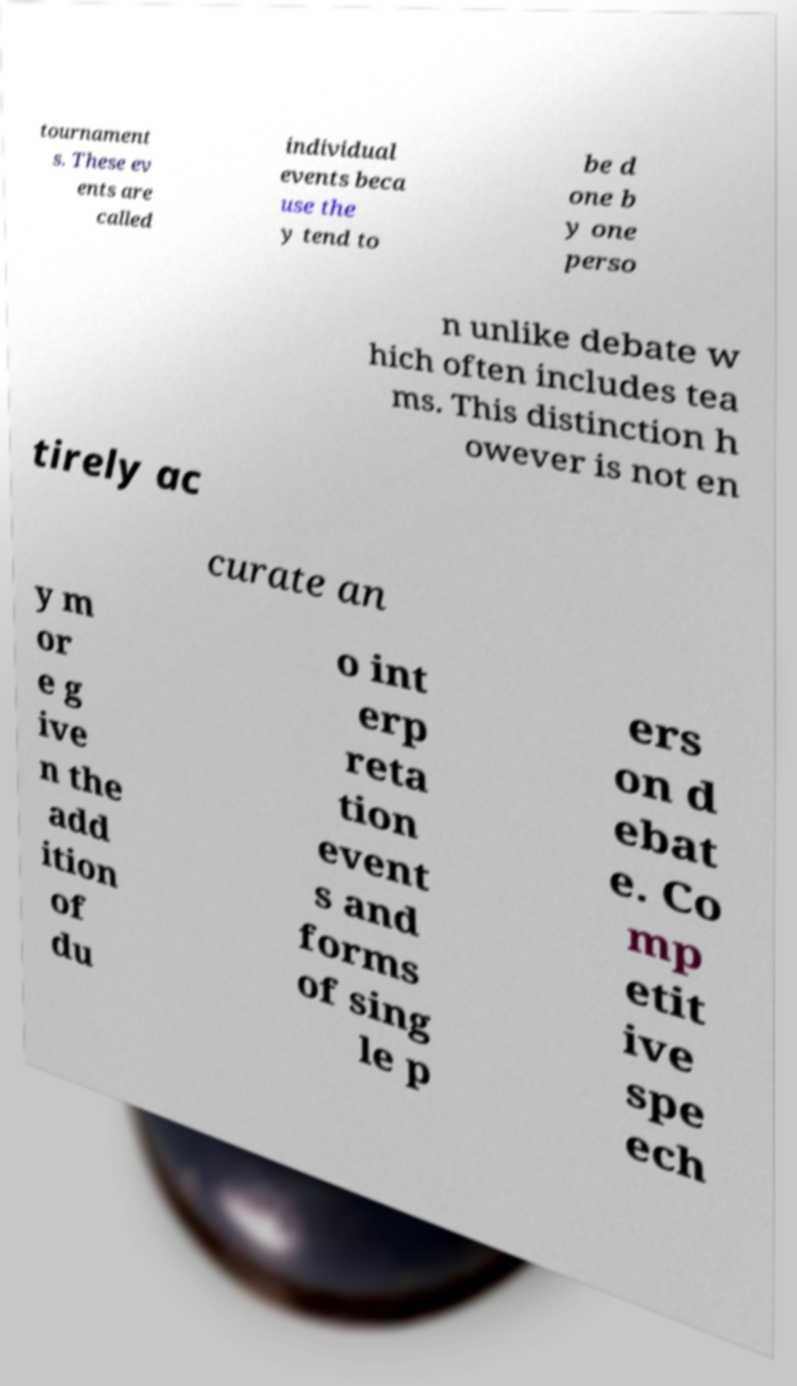Please identify and transcribe the text found in this image. tournament s. These ev ents are called individual events beca use the y tend to be d one b y one perso n unlike debate w hich often includes tea ms. This distinction h owever is not en tirely ac curate an y m or e g ive n the add ition of du o int erp reta tion event s and forms of sing le p ers on d ebat e. Co mp etit ive spe ech 